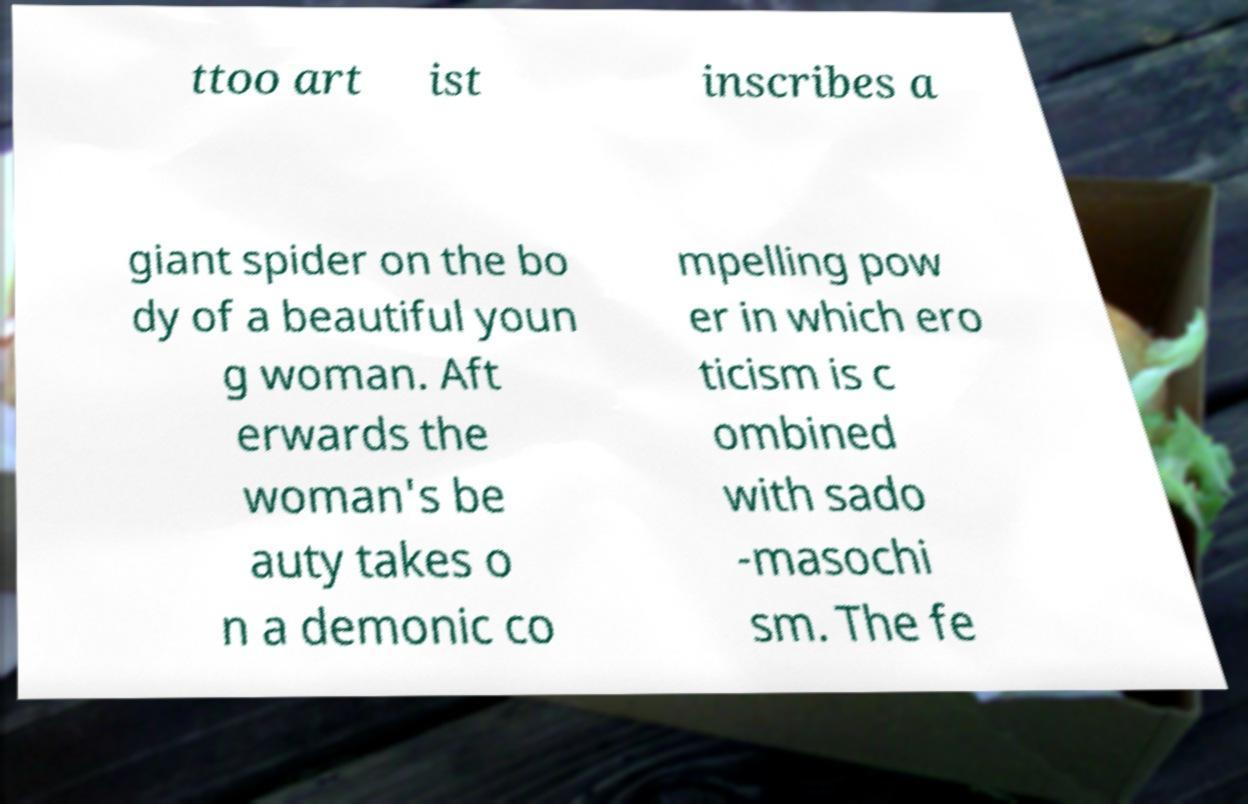Can you accurately transcribe the text from the provided image for me? ttoo art ist inscribes a giant spider on the bo dy of a beautiful youn g woman. Aft erwards the woman's be auty takes o n a demonic co mpelling pow er in which ero ticism is c ombined with sado -masochi sm. The fe 